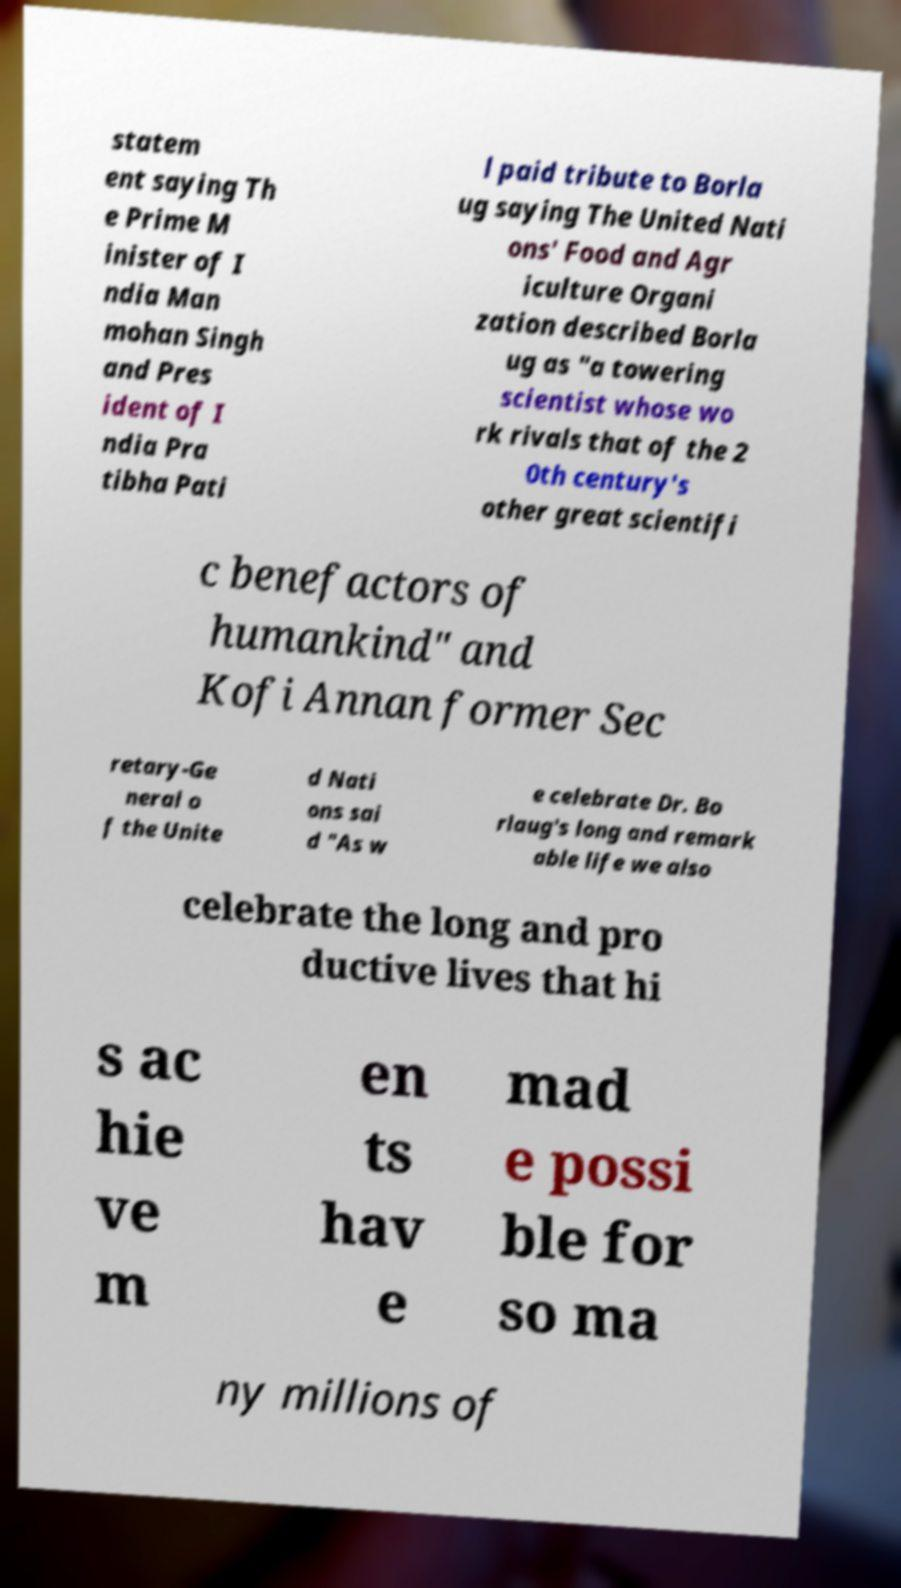For documentation purposes, I need the text within this image transcribed. Could you provide that? statem ent saying Th e Prime M inister of I ndia Man mohan Singh and Pres ident of I ndia Pra tibha Pati l paid tribute to Borla ug saying The United Nati ons' Food and Agr iculture Organi zation described Borla ug as "a towering scientist whose wo rk rivals that of the 2 0th century's other great scientifi c benefactors of humankind" and Kofi Annan former Sec retary-Ge neral o f the Unite d Nati ons sai d "As w e celebrate Dr. Bo rlaug's long and remark able life we also celebrate the long and pro ductive lives that hi s ac hie ve m en ts hav e mad e possi ble for so ma ny millions of 